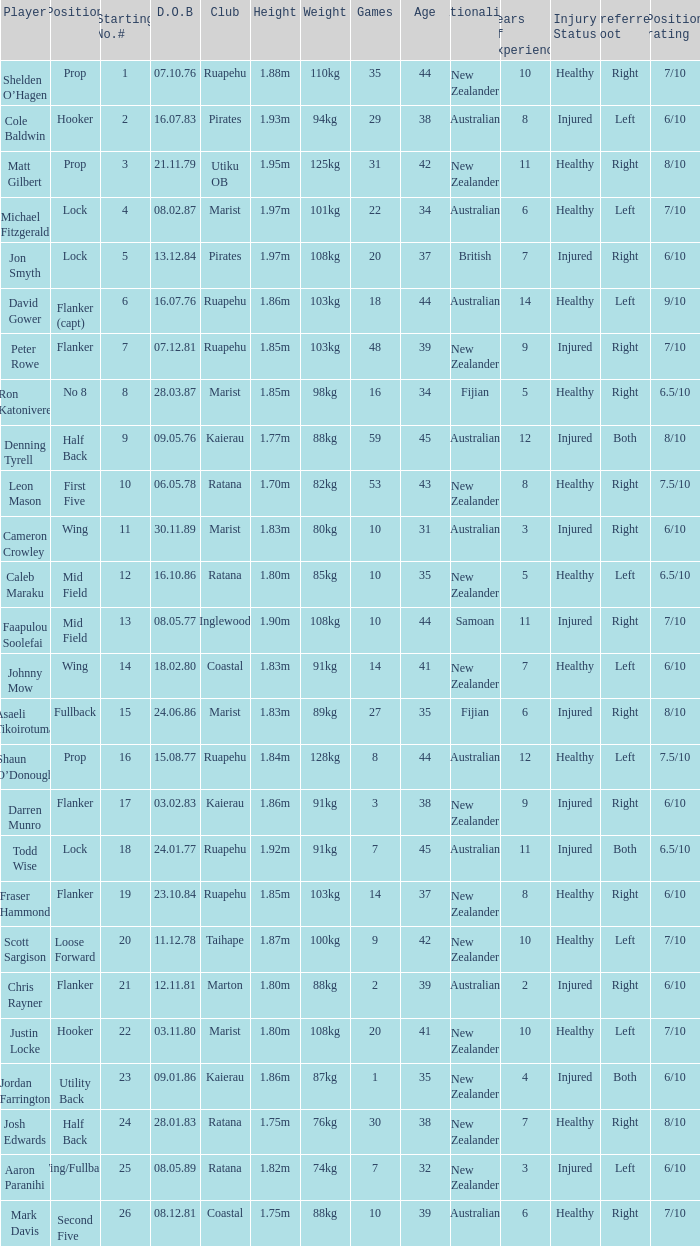What is the date of birth for the player in the Inglewood club? 80577.0. 